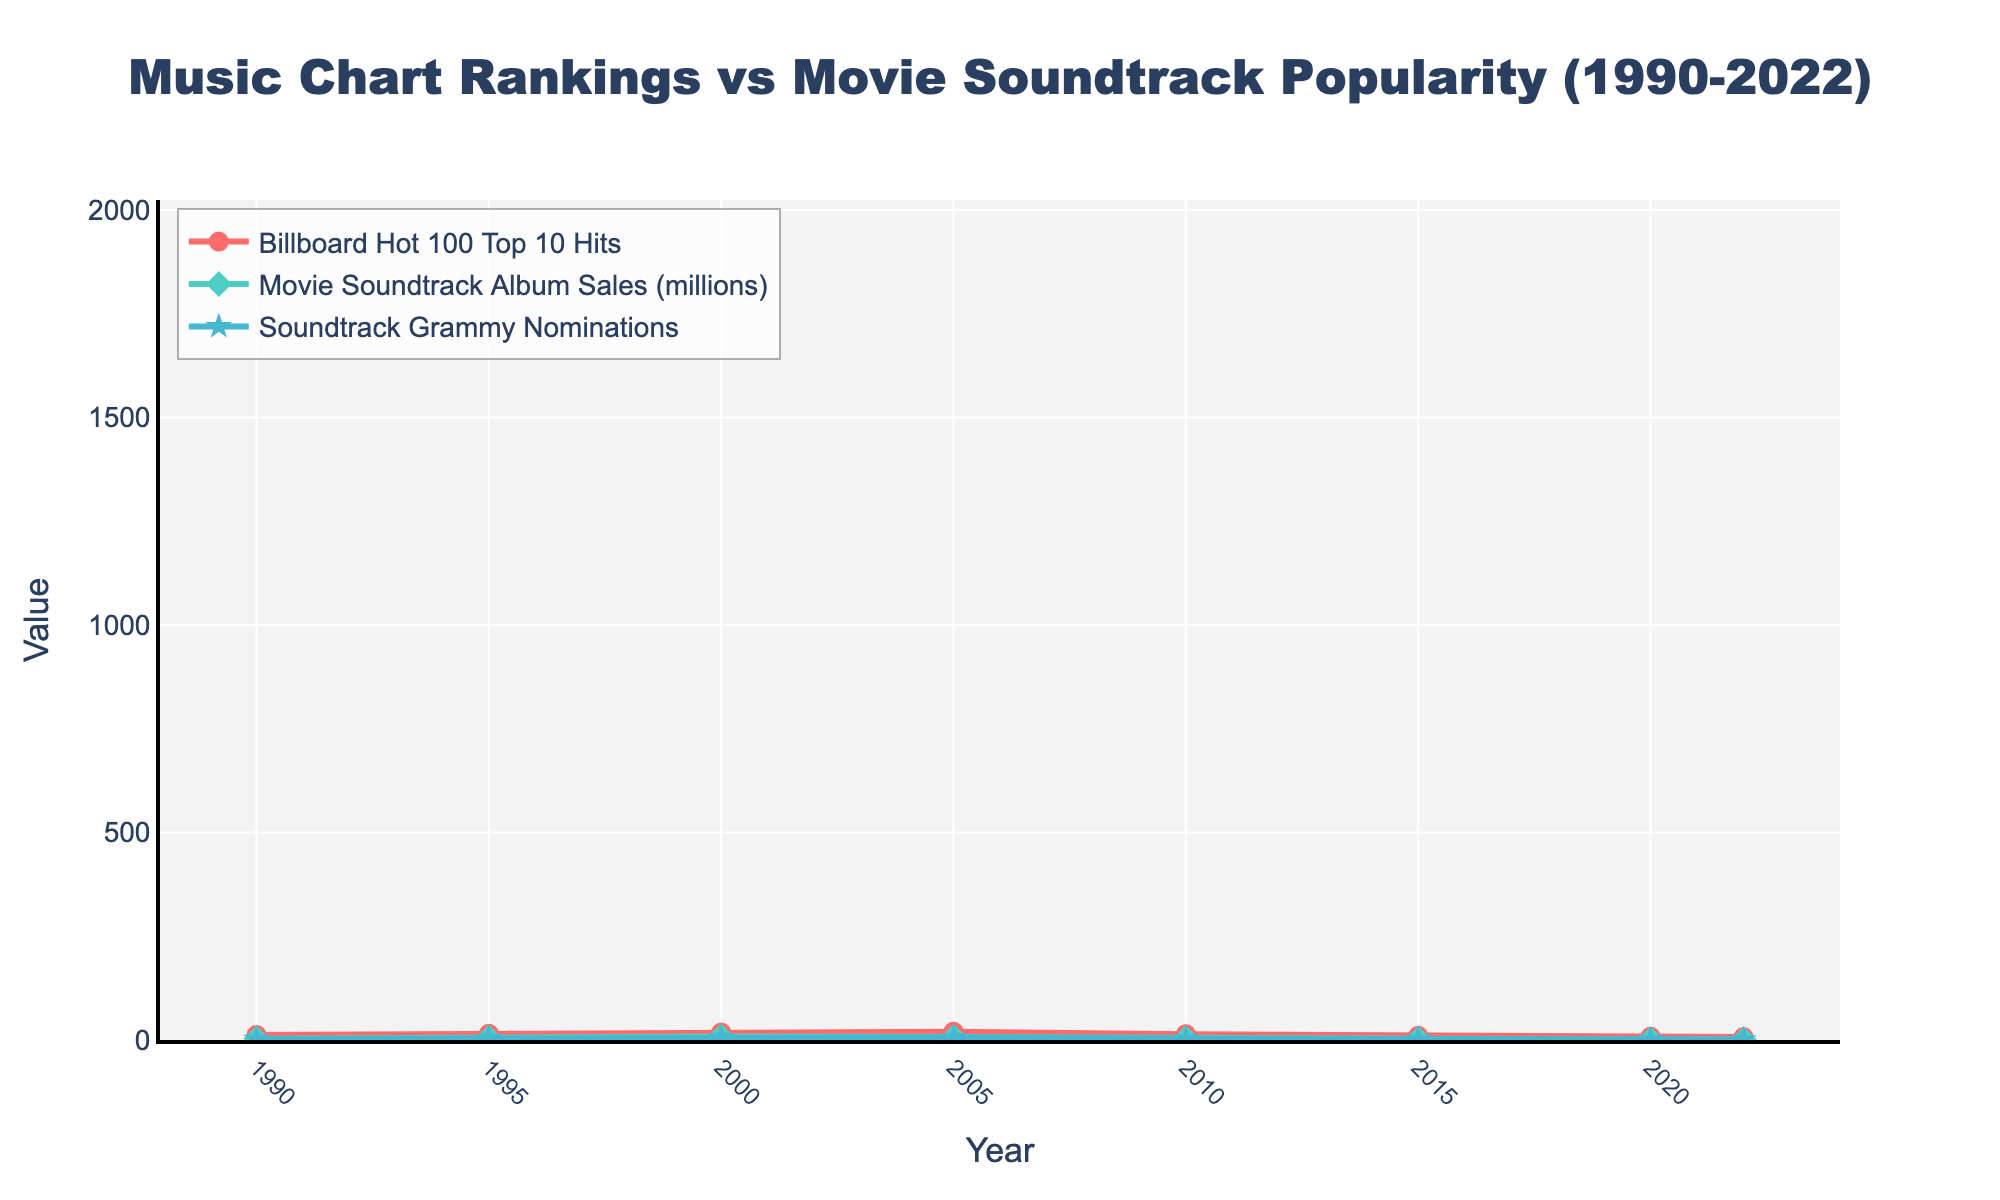Which year had the highest number of Billboard Hot 100 Top 10 Hits? The line chart shows the number of Billboard Hot 100 Top 10 Hits peaking at 20 in the year 2005.
Answer: 2005 In which year were the Movie Soundtrack Album Sales the lowest? The line for Movie Soundtrack Album Sales drops to its lowest value of 1.2 million in the year 2022.
Answer: 2022 What is the difference in Soundtrack Grammy Nominations between the year 2000 and 2022? In the year 2000, there were 5 Soundtrack Grammy Nominations, while in 2022 there was only 1. The difference is 5 - 1 = 4.
Answer: 4 How many times did the number of Billboard Hot 100 Top 10 Hits surpass 15 between 1990 and 2022? By counting the points on the Billboard Hot 100 Top 10 Hits line that are greater than 15, we see they surpassed 15 in the years 2000 and 2005.
Answer: 2 Between which two consecutive years did Movie Soundtrack Album Sales see the largest increase? By examining the line for Movie Soundtrack Album Sales, the largest increase occurs between 1990 and 1995, where sales went from 3.2 million to 5.8 million.
Answer: 1990 and 1995 In which year did all three metrics (Billboard Hot 100 Top 10 Hits, Movie Soundtrack Album Sales, Soundtrack Grammy Nominations) reach their maximum values? Evaluating each line, all three metrics reached their peaks in different years, therefore no single year saw the maximum for all.
Answer: No such year What is the average number of Billboard Hot 100 Top 10 Hits from 1990 to 2022? Summing the number of Billboard Hot 100 Top 10 Hits from each year (12 + 15 + 18 + 20 + 14 + 10 + 8 + 7) = 104, then dividing by the number of years (8), the average is 104 / 8 = 13.
Answer: 13 What is the ratio of Movie Soundtrack Album Sales to Billboard Hot 100 Top 10 Hits in 2010? In 2010, Movie Soundtrack Album Sales were 4.1 million and Billboard Hot 100 Top 10 Hits were 14. The ratio is 4.1 / 14 ≈ 0.29.
Answer: 0.29 Which metric experienced the sharpest overall decline from 1990 to 2022? Observing the slopes from 1990 to 2022, Movie Soundtrack Album Sales dropped from 3.2 million to 1.2 million. This is the sharpest overall decline compared to the other metrics.
Answer: Movie Soundtrack Album Sales Between which years did the number of Soundtrack Grammy Nominations remain unchanged? On the plot, we see that the number of Soundtrack Grammy Nominations was the same (2 nominations) in 2015 and 2020.
Answer: 2015 and 2020 